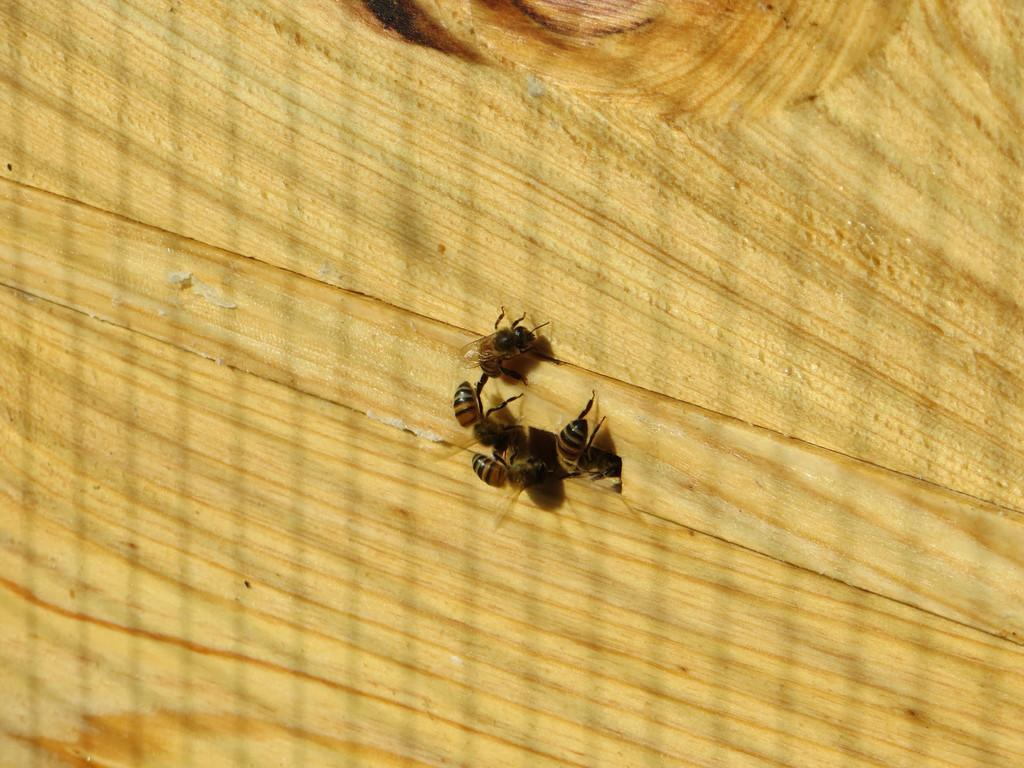What type of insects can be seen in the image? There are honey bees in the image. What surface are the honey bees on? The honey bees are on a wooden object. What type of whistle can be heard coming from the honey bees in the image? There is no whistle present in the image, as honey bees do not make whistling sounds. 